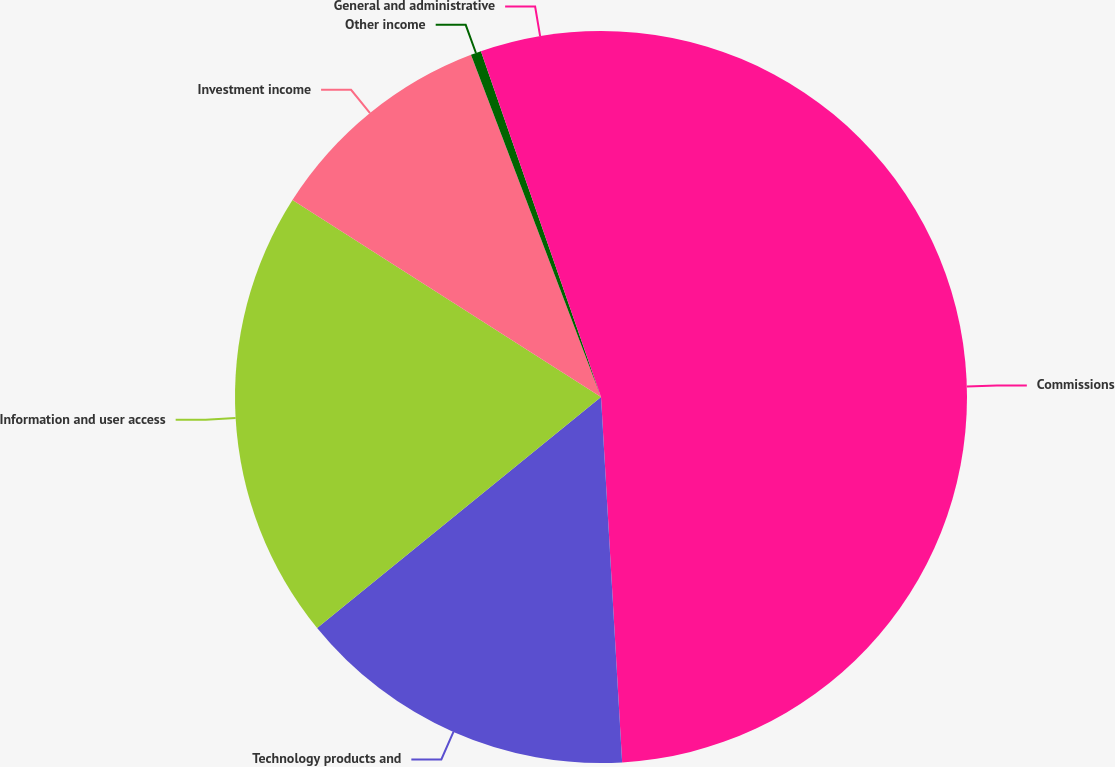<chart> <loc_0><loc_0><loc_500><loc_500><pie_chart><fcel>Commissions<fcel>Technology products and<fcel>Information and user access<fcel>Investment income<fcel>Other income<fcel>General and administrative<nl><fcel>49.08%<fcel>15.05%<fcel>19.91%<fcel>10.18%<fcel>0.46%<fcel>5.32%<nl></chart> 